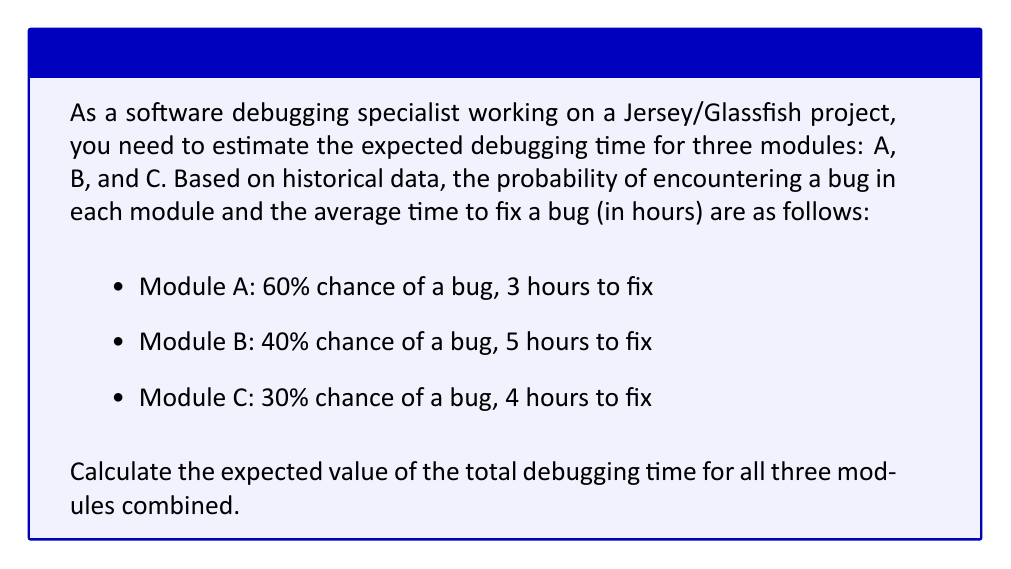Could you help me with this problem? To solve this problem, we need to calculate the expected debugging time for each module individually and then sum them up. Let's break it down step by step:

1. Calculate the expected debugging time for Module A:
   $$E(A) = P(\text{bug in A}) \times \text{Time to fix bug in A}$$
   $$E(A) = 0.60 \times 3 = 1.8 \text{ hours}$$

2. Calculate the expected debugging time for Module B:
   $$E(B) = P(\text{bug in B}) \times \text{Time to fix bug in B}$$
   $$E(B) = 0.40 \times 5 = 2.0 \text{ hours}$$

3. Calculate the expected debugging time for Module C:
   $$E(C) = P(\text{bug in C}) \times \text{Time to fix bug in C}$$
   $$E(C) = 0.30 \times 4 = 1.2 \text{ hours}$$

4. Sum up the expected debugging times for all three modules:
   $$E(\text{Total}) = E(A) + E(B) + E(C)$$
   $$E(\text{Total}) = 1.8 + 2.0 + 1.2 = 5.0 \text{ hours}$$

Therefore, the expected value of the total debugging time for all three modules combined is 5.0 hours.
Answer: 5.0 hours 